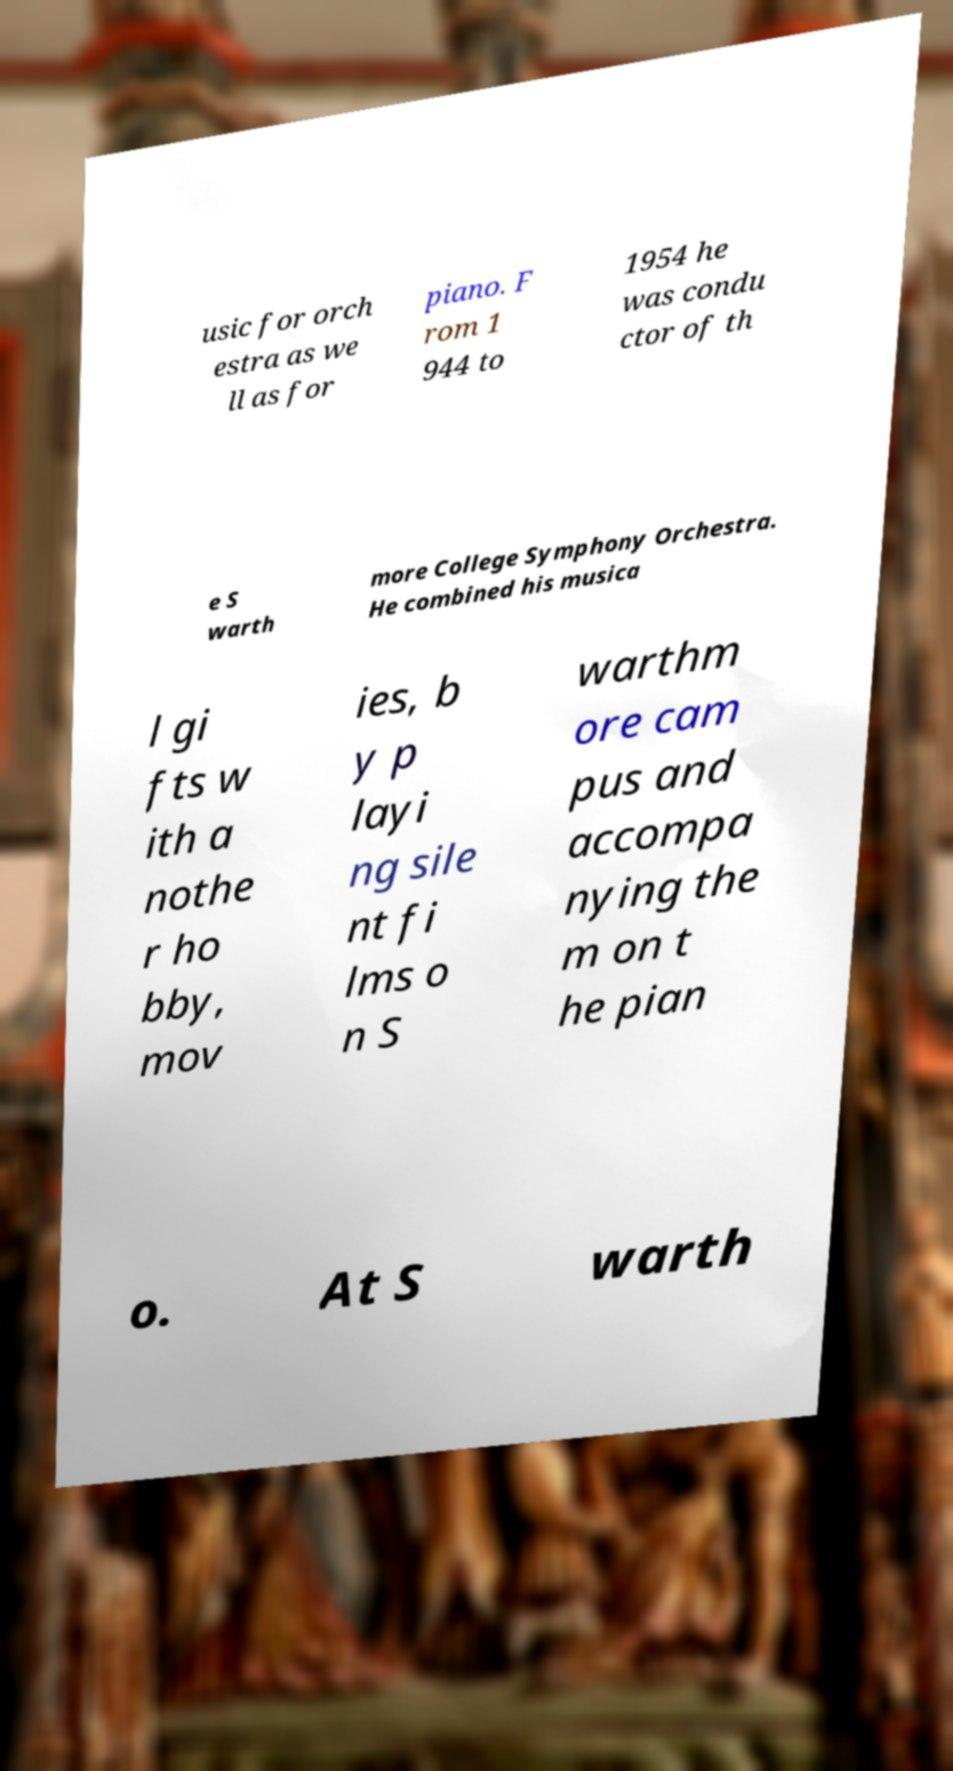Could you extract and type out the text from this image? usic for orch estra as we ll as for piano. F rom 1 944 to 1954 he was condu ctor of th e S warth more College Symphony Orchestra. He combined his musica l gi fts w ith a nothe r ho bby, mov ies, b y p layi ng sile nt fi lms o n S warthm ore cam pus and accompa nying the m on t he pian o. At S warth 